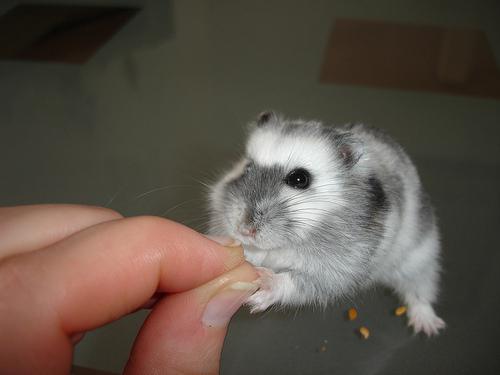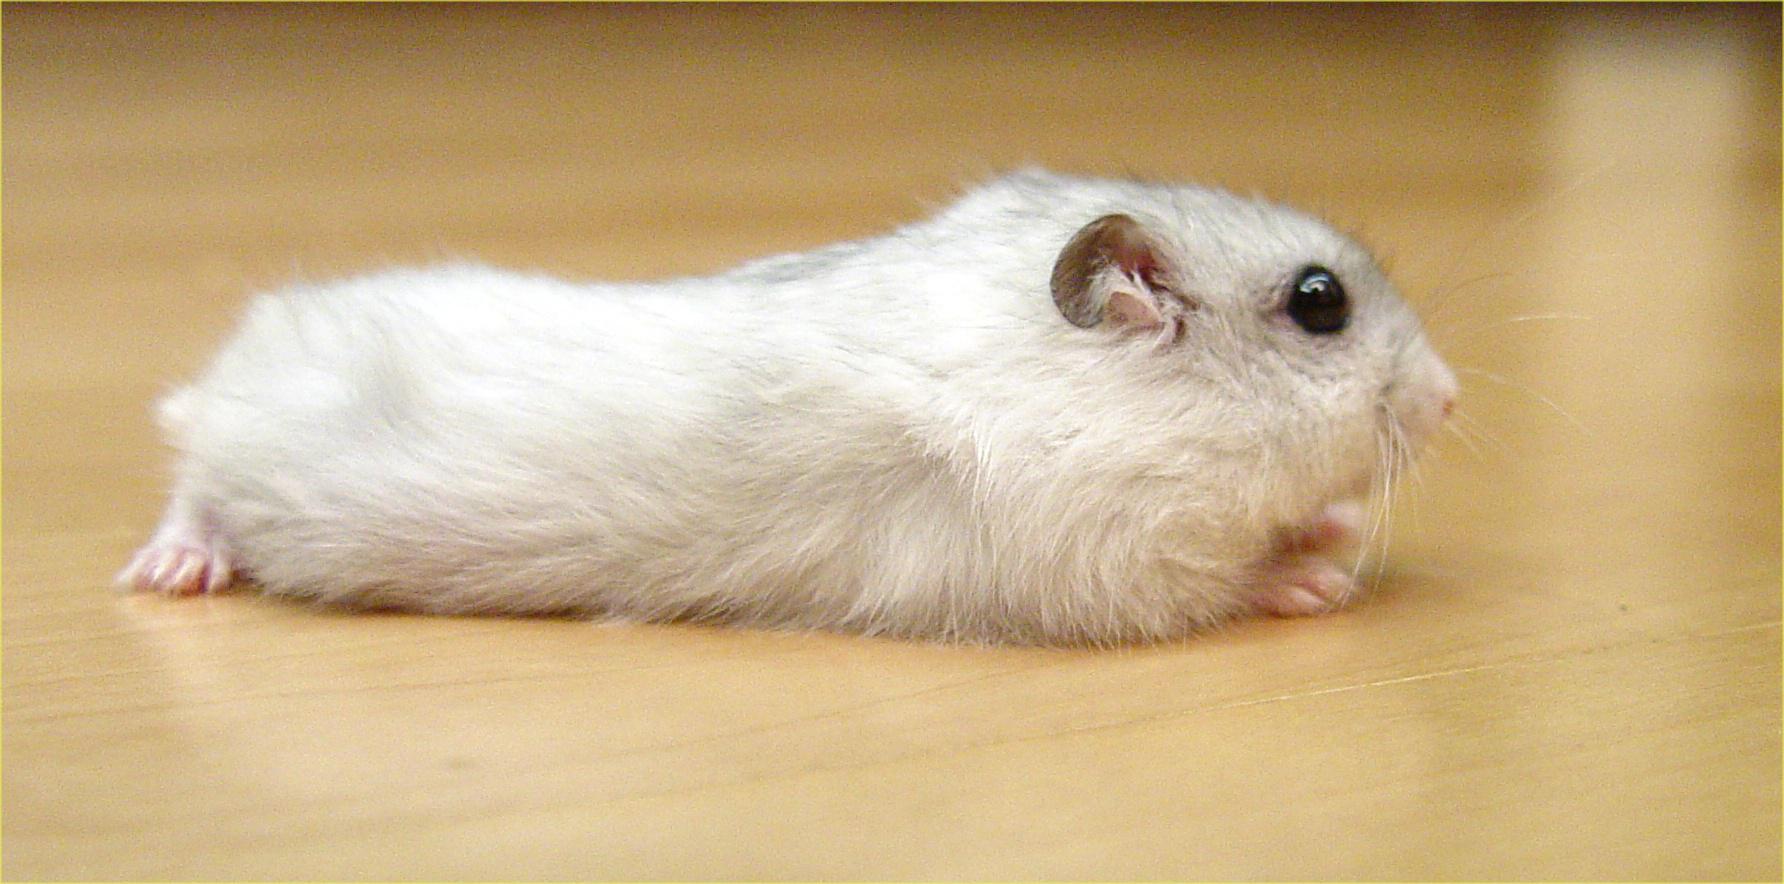The first image is the image on the left, the second image is the image on the right. For the images shown, is this caption "A rodent is lying across a flat glossy surface in one of the images." true? Answer yes or no. Yes. The first image is the image on the left, the second image is the image on the right. Examine the images to the left and right. Is the description "An image shows one rodent pet lying with its belly flat on a light-colored wood surface." accurate? Answer yes or no. Yes. 